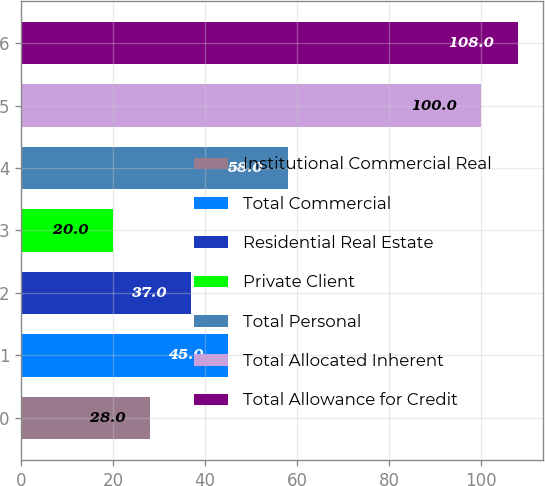Convert chart to OTSL. <chart><loc_0><loc_0><loc_500><loc_500><bar_chart><fcel>Institutional Commercial Real<fcel>Total Commercial<fcel>Residential Real Estate<fcel>Private Client<fcel>Total Personal<fcel>Total Allocated Inherent<fcel>Total Allowance for Credit<nl><fcel>28<fcel>45<fcel>37<fcel>20<fcel>58<fcel>100<fcel>108<nl></chart> 